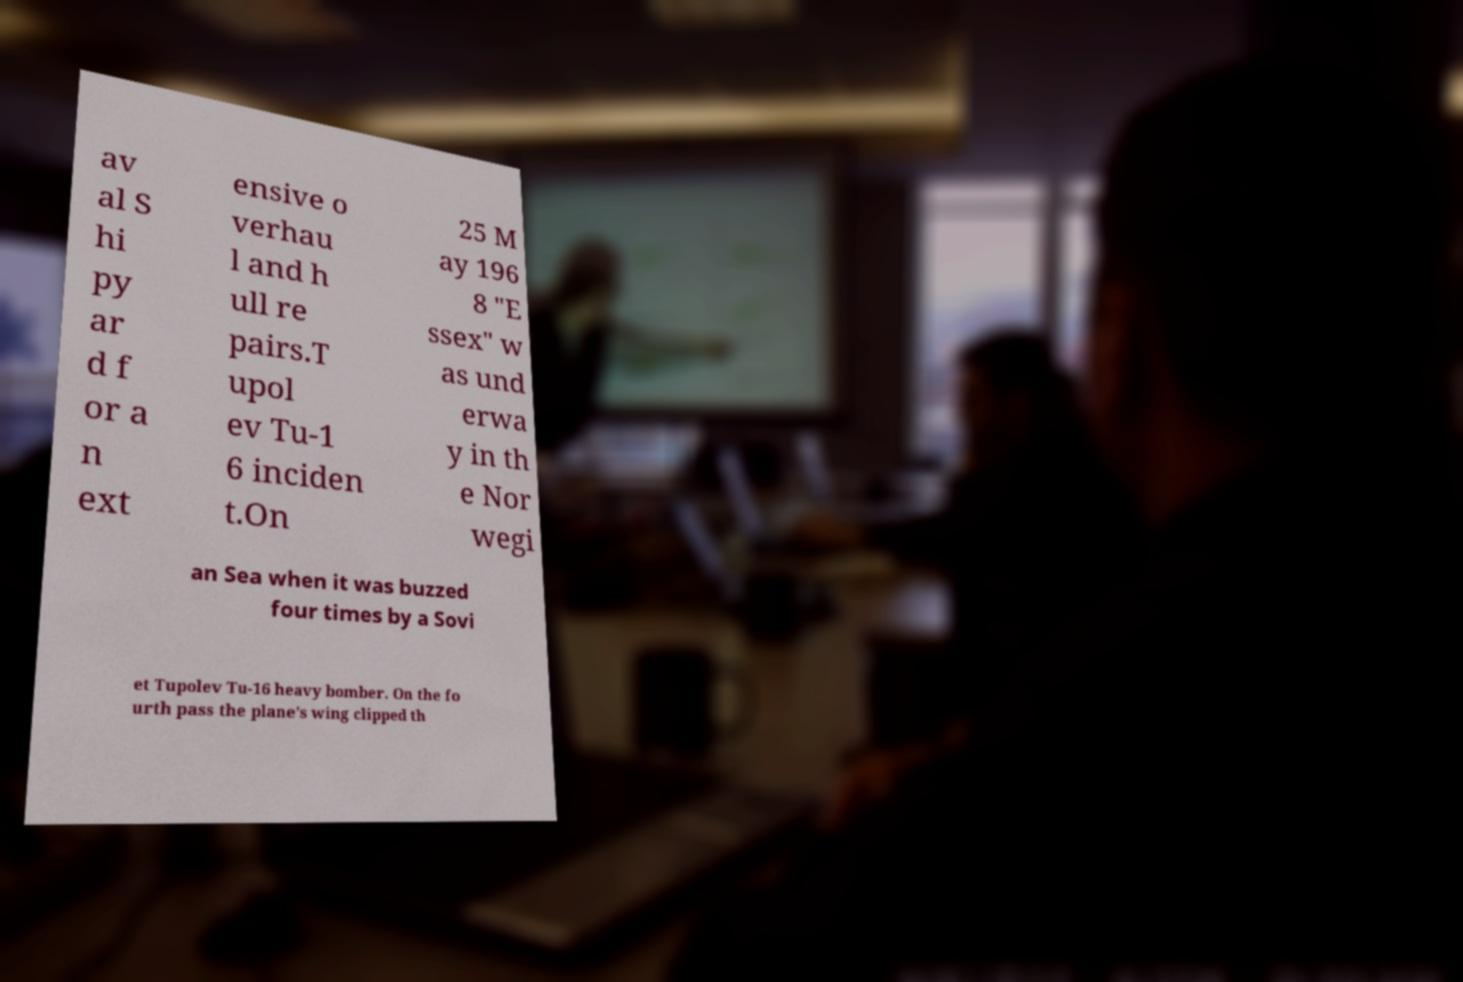Please read and relay the text visible in this image. What does it say? av al S hi py ar d f or a n ext ensive o verhau l and h ull re pairs.T upol ev Tu-1 6 inciden t.On 25 M ay 196 8 "E ssex" w as und erwa y in th e Nor wegi an Sea when it was buzzed four times by a Sovi et Tupolev Tu-16 heavy bomber. On the fo urth pass the plane's wing clipped th 